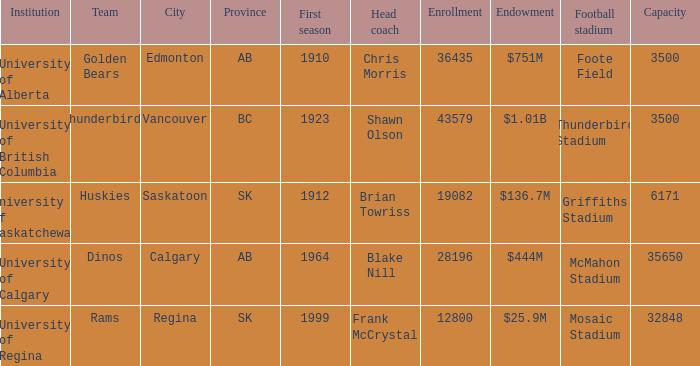How many cities have an enrollment of 19082? 1.0. 